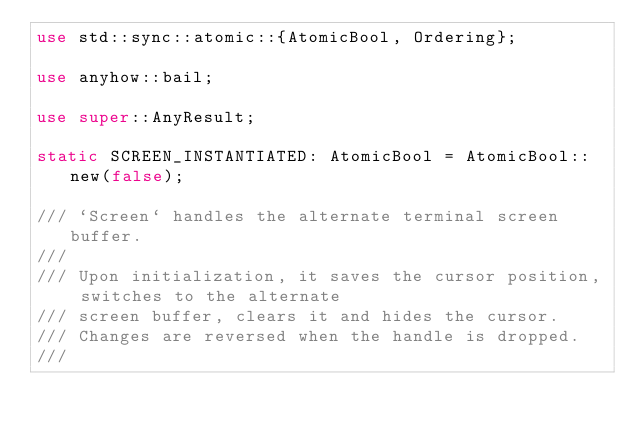Convert code to text. <code><loc_0><loc_0><loc_500><loc_500><_Rust_>use std::sync::atomic::{AtomicBool, Ordering};

use anyhow::bail;

use super::AnyResult;

static SCREEN_INSTANTIATED: AtomicBool = AtomicBool::new(false);

/// `Screen` handles the alternate terminal screen buffer.
///
/// Upon initialization, it saves the cursor position, switches to the alternate
/// screen buffer, clears it and hides the cursor.
/// Changes are reversed when the handle is dropped.
///</code> 